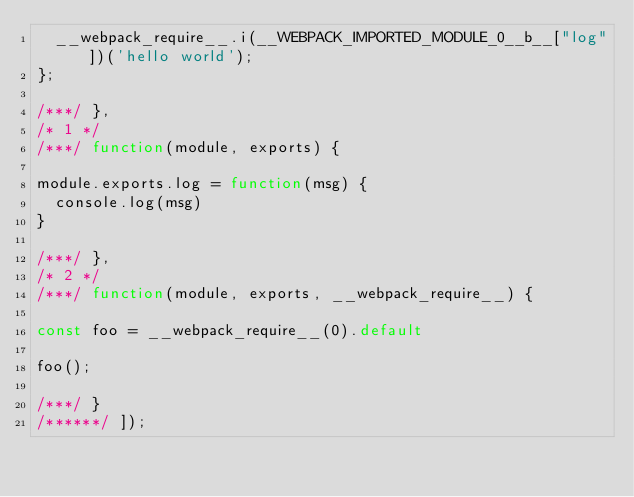<code> <loc_0><loc_0><loc_500><loc_500><_JavaScript_>	__webpack_require__.i(__WEBPACK_IMPORTED_MODULE_0__b__["log"])('hello world');
};

/***/ },
/* 1 */
/***/ function(module, exports) {

module.exports.log = function(msg) {
	console.log(msg)
}

/***/ },
/* 2 */
/***/ function(module, exports, __webpack_require__) {

const foo = __webpack_require__(0).default

foo();

/***/ }
/******/ ]);</code> 